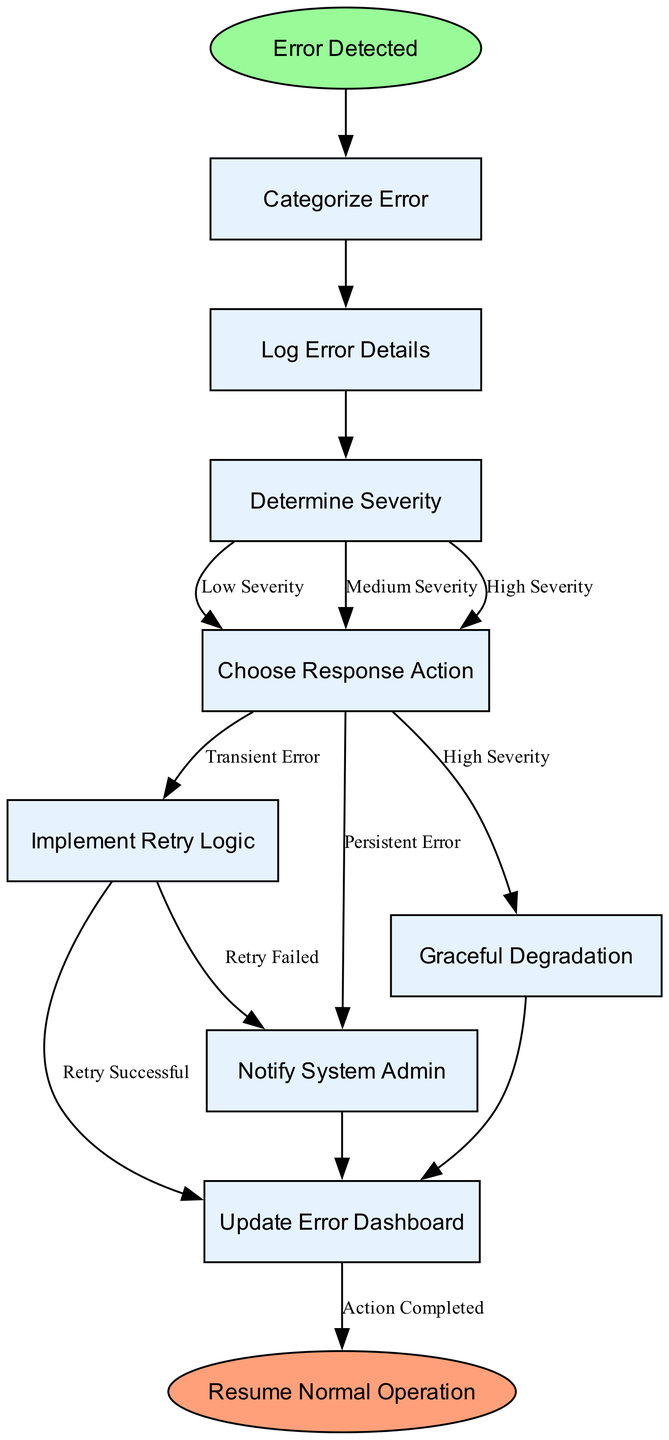What is the first step after an error is detected? The diagram indicates that the first step after "Error Detected" is to "Categorize Error." This step is the immediate next node from the start node.
Answer: Categorize Error How many nodes are present in the flowchart? The diagram comprises eight nodes: "Error Detected," "Categorize Error," "Log Error Details," "Determine Severity," "Choose Response Action," "Implement Retry Logic," "Notify System Admin," "Graceful Degradation," and "Update Error Dashboard." Thus, the total is nine nodes.
Answer: Nine What are the response actions for a persistent error? In the flowchart, the response action for a persistent error, which follows the "Choose Response Action" node, is to "Notify System Admin." This can be determined by tracing back from "Persistent Error."
Answer: Notify System Admin Which node is labeled as low severity? The diagram does not have distinct nodes labeled as "Low Severity" directly, as it is used as a label on the edge connecting "Determine Severity" to "Choose Response Action". Thus, there is no uniquely labeled node for low severity in the chart.
Answer: None What happens if the retry logic is successful? According to the diagram, if the "Implement Retry Logic" step is successful, the next node is "Update Error Dashboard." This can be traced directly from the successful edge stemming from "Implement Retry Logic."
Answer: Update Error Dashboard What is the final outcome after completing all actions? The final outcome indicated in the flowchart after completing all actions leads to the end node labeled "Resume Normal Operation." This is the endpoint of the entire process shown in the flowchart.
Answer: Resume Normal Operation If the error is categorized as high severity, which action is taken? When the error is categorized as high severity, the flowchart indicates the action taken is "Graceful Degradation". This is indicated by the edge labeled with "High Severity" coming from "Choose Response Action."
Answer: Graceful Degradation How does the flowchart handle a transient error? In the flowchart, if the error is categorized as transient, it leads to "Implement Retry Logic." This is represented by the edge labeled with "Transient Error" from the "Choose Response Action."
Answer: Implement Retry Logic 